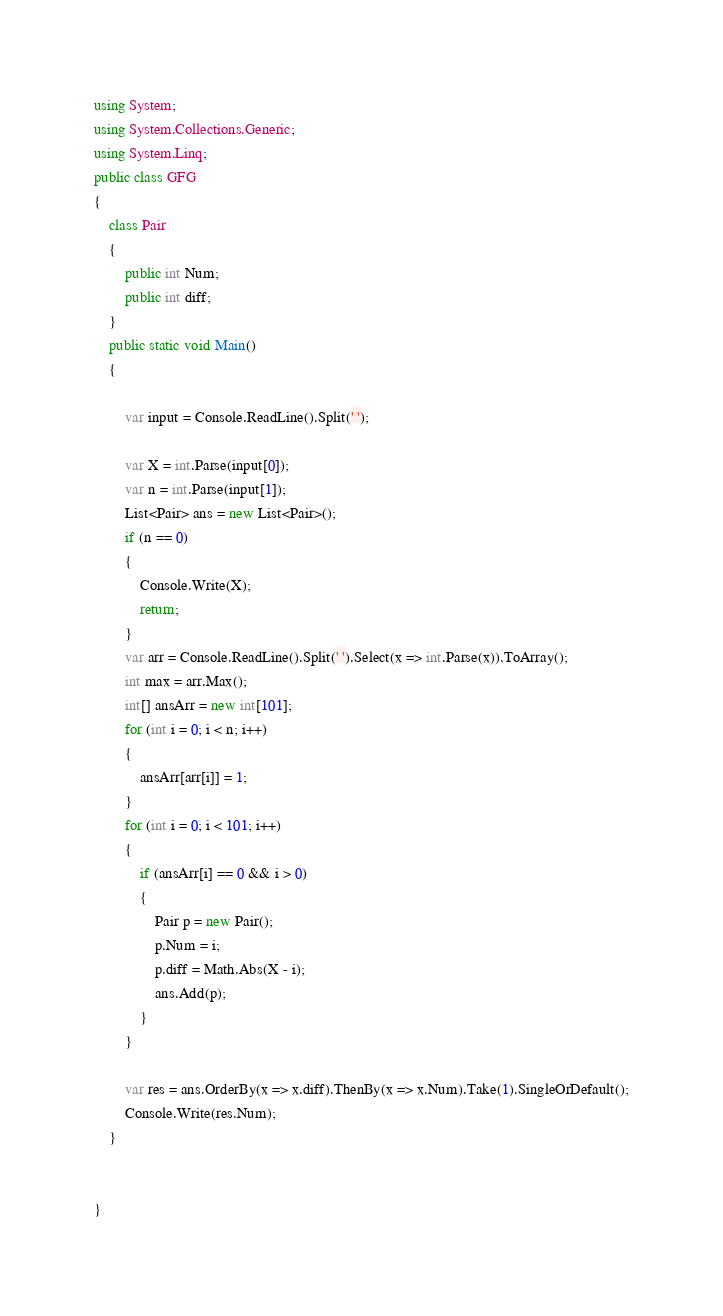Convert code to text. <code><loc_0><loc_0><loc_500><loc_500><_C#_>using System;
using System.Collections.Generic;
using System.Linq;
public class GFG
{
    class Pair
    {
        public int Num;
        public int diff;
    }
    public static void Main()
    {

        var input = Console.ReadLine().Split(' ');

        var X = int.Parse(input[0]);
        var n = int.Parse(input[1]);
        List<Pair> ans = new List<Pair>();
        if (n == 0)
        {
            Console.Write(X);
            return;
        }
        var arr = Console.ReadLine().Split(' ').Select(x => int.Parse(x)).ToArray();
        int max = arr.Max();
        int[] ansArr = new int[101];
        for (int i = 0; i < n; i++)
        {
            ansArr[arr[i]] = 1;
        }
        for (int i = 0; i < 101; i++)
        {
            if (ansArr[i] == 0 && i > 0)
            {
                Pair p = new Pair();
                p.Num = i;
                p.diff = Math.Abs(X - i);
                ans.Add(p);
            }
        }

        var res = ans.OrderBy(x => x.diff).ThenBy(x => x.Num).Take(1).SingleOrDefault();
        Console.Write(res.Num);
    }


}
</code> 